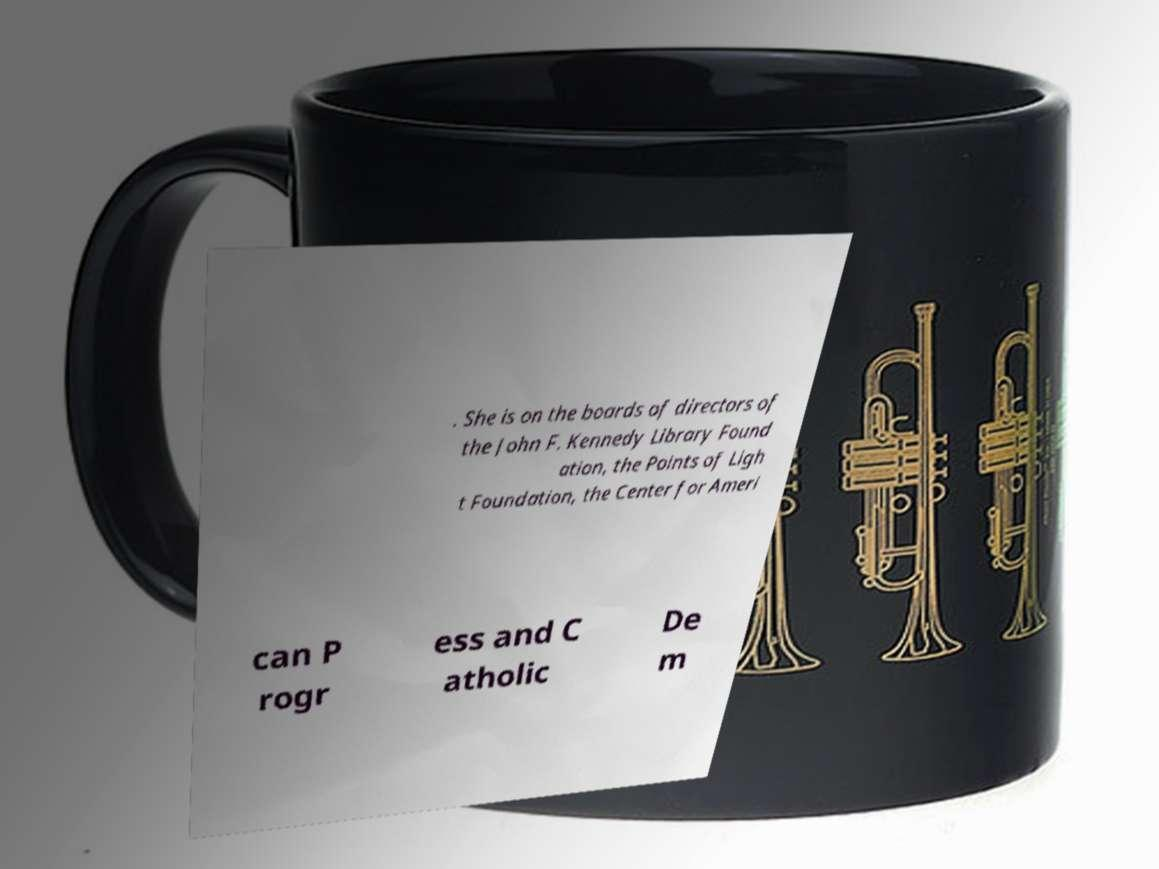Could you extract and type out the text from this image? . She is on the boards of directors of the John F. Kennedy Library Found ation, the Points of Ligh t Foundation, the Center for Ameri can P rogr ess and C atholic De m 